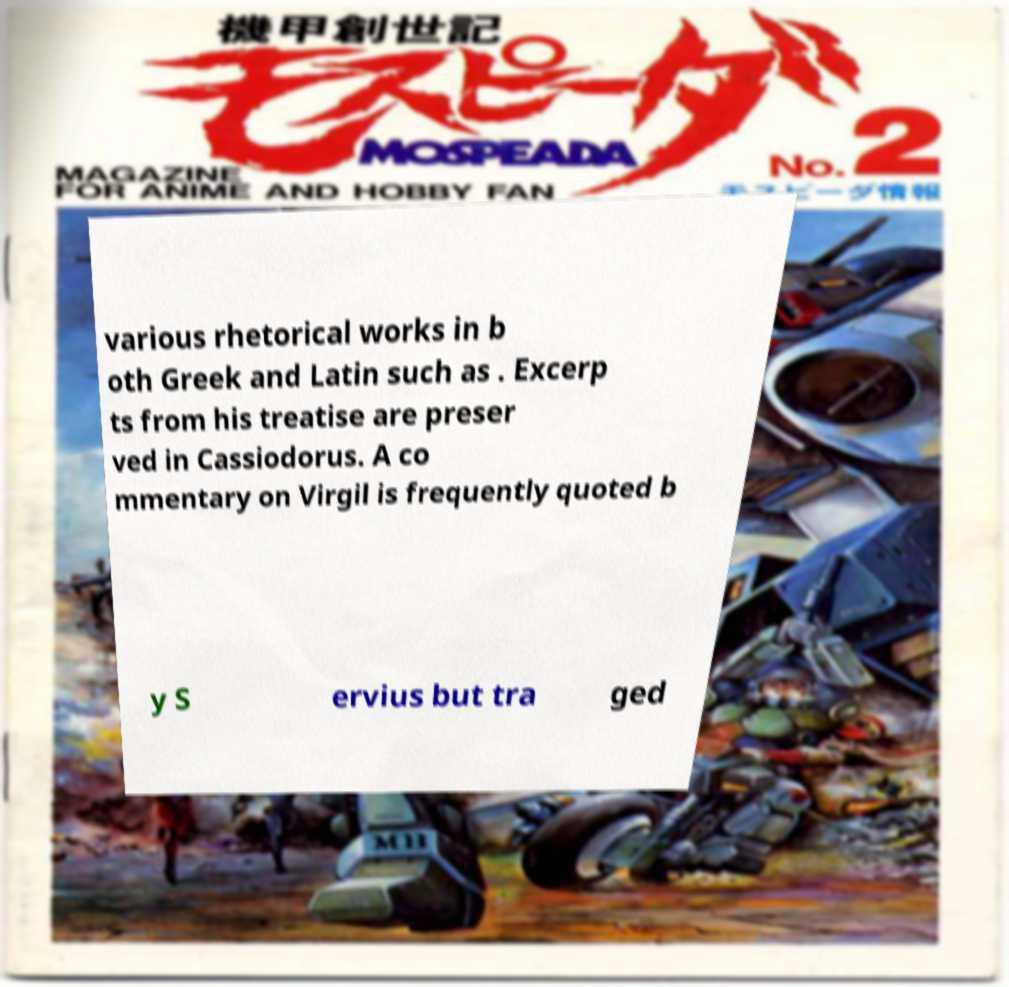Can you accurately transcribe the text from the provided image for me? various rhetorical works in b oth Greek and Latin such as . Excerp ts from his treatise are preser ved in Cassiodorus. A co mmentary on Virgil is frequently quoted b y S ervius but tra ged 